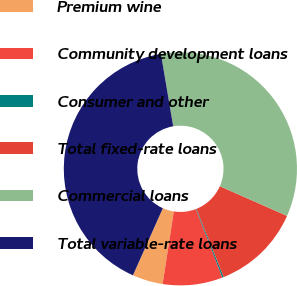Convert chart to OTSL. <chart><loc_0><loc_0><loc_500><loc_500><pie_chart><fcel>Premium wine<fcel>Community development loans<fcel>Consumer and other<fcel>Total fixed-rate loans<fcel>Commercial loans<fcel>Total variable-rate loans<nl><fcel>4.24%<fcel>8.29%<fcel>0.2%<fcel>12.33%<fcel>34.28%<fcel>40.65%<nl></chart> 